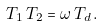Convert formula to latex. <formula><loc_0><loc_0><loc_500><loc_500>T _ { 1 } \, T _ { 2 } = \omega \, T _ { d } \, .</formula> 